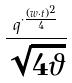Convert formula to latex. <formula><loc_0><loc_0><loc_500><loc_500>\frac { q ^ { \cdot \frac { ( w \cdot t ) ^ { 2 } } { 4 } } } { \sqrt { 4 \vartheta } }</formula> 